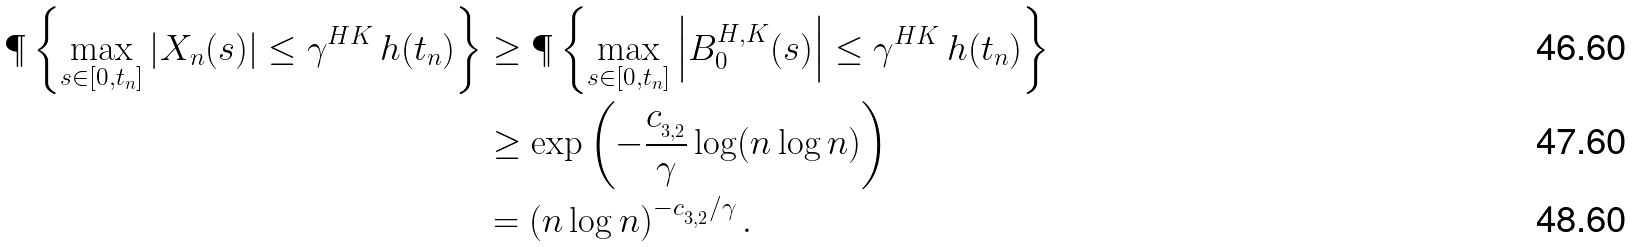<formula> <loc_0><loc_0><loc_500><loc_500>\P \left \{ \max _ { s \in [ 0 , t _ { n } ] } \left | X _ { n } ( s ) \right | \leq \gamma ^ { H K } \, h ( t _ { n } ) \right \} & \geq \P \left \{ \max _ { s \in [ 0 , t _ { n } ] } \left | B ^ { H , K } _ { 0 } ( s ) \right | \leq \gamma ^ { H K } \, h ( t _ { n } ) \right \} \\ & \geq \exp \left ( - \frac { c _ { _ { 3 , 2 } } } { \gamma } \log ( n \log n ) \right ) \\ & = \left ( n \log n \right ) ^ { - c _ { _ { 3 , 2 } } / \gamma } .</formula> 